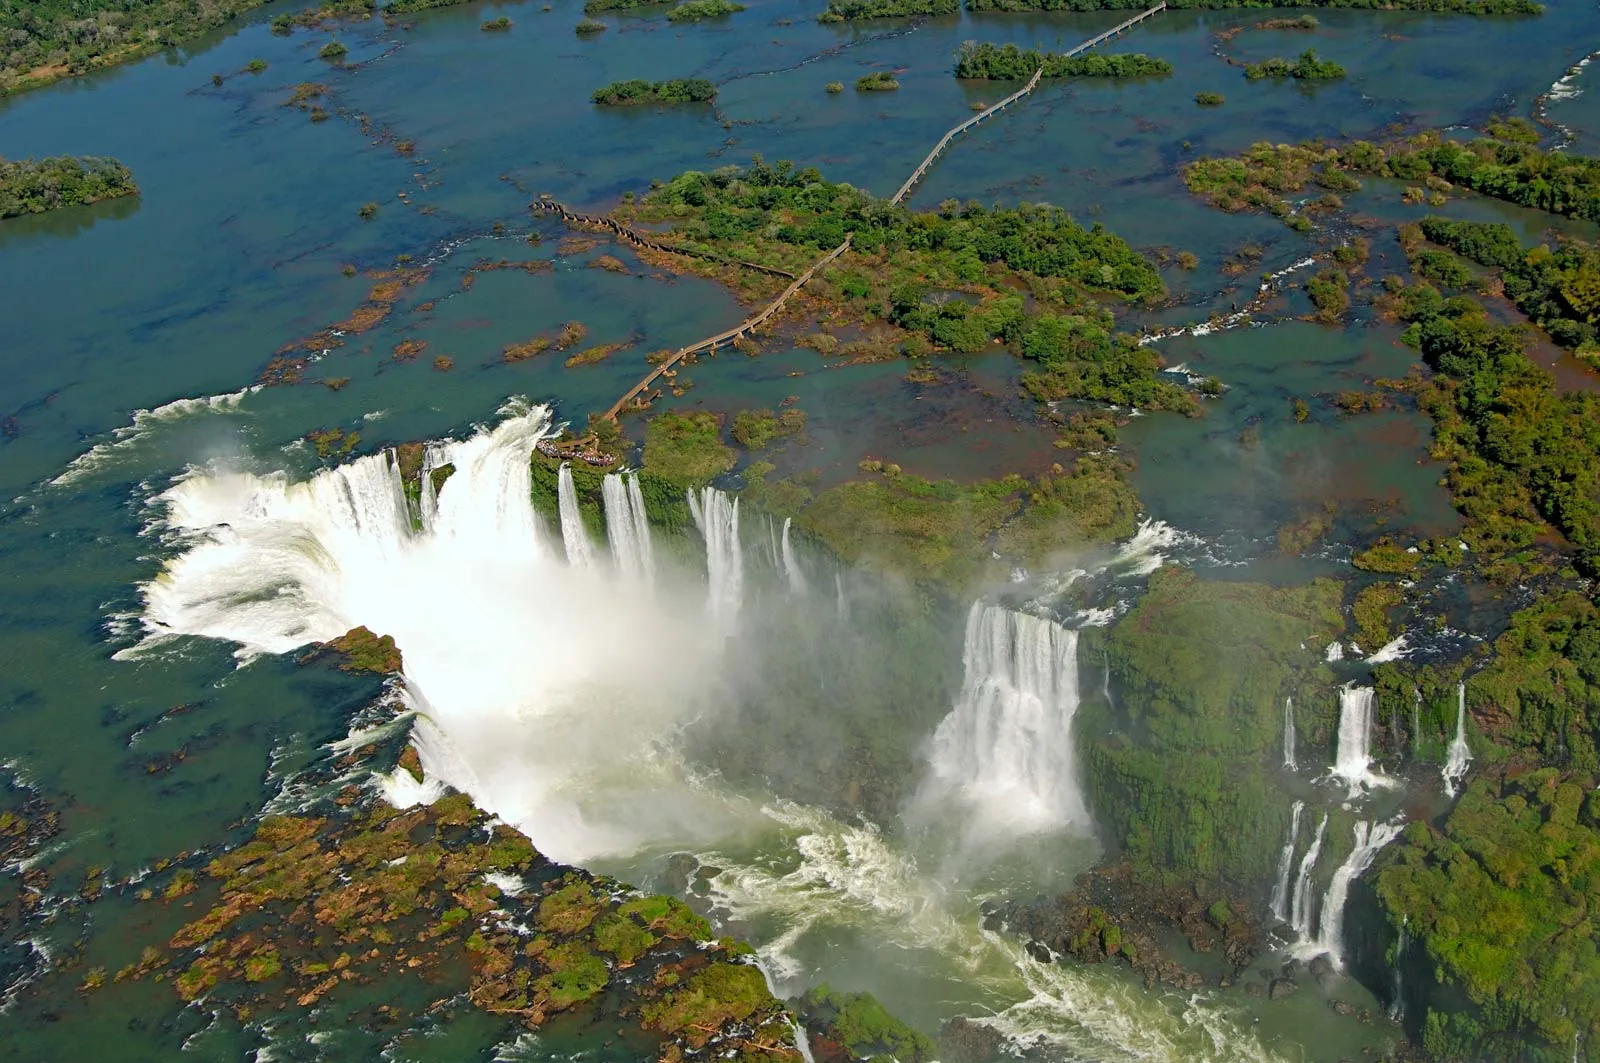If you could step into this picture, what sounds and sensations would you experience? Stepping into this scene, you would be greeted by the thunderous roar of the cascading water, a sound so powerful it can be felt vibrating through the ground. The air would be filled with a fine, cool mist that gently coats your skin, a refreshing sensation amplified by the moisture-laden breeze. As you stand at the edge, the sheer volume and force of the rushing water would create a sense of awe and insignificance, a humbling reminder of nature’s power. The verdant aroma of the surrounding forest, mixed with the fresh scent of the water, would fill your lungs, completing the immersive sensory experience. 